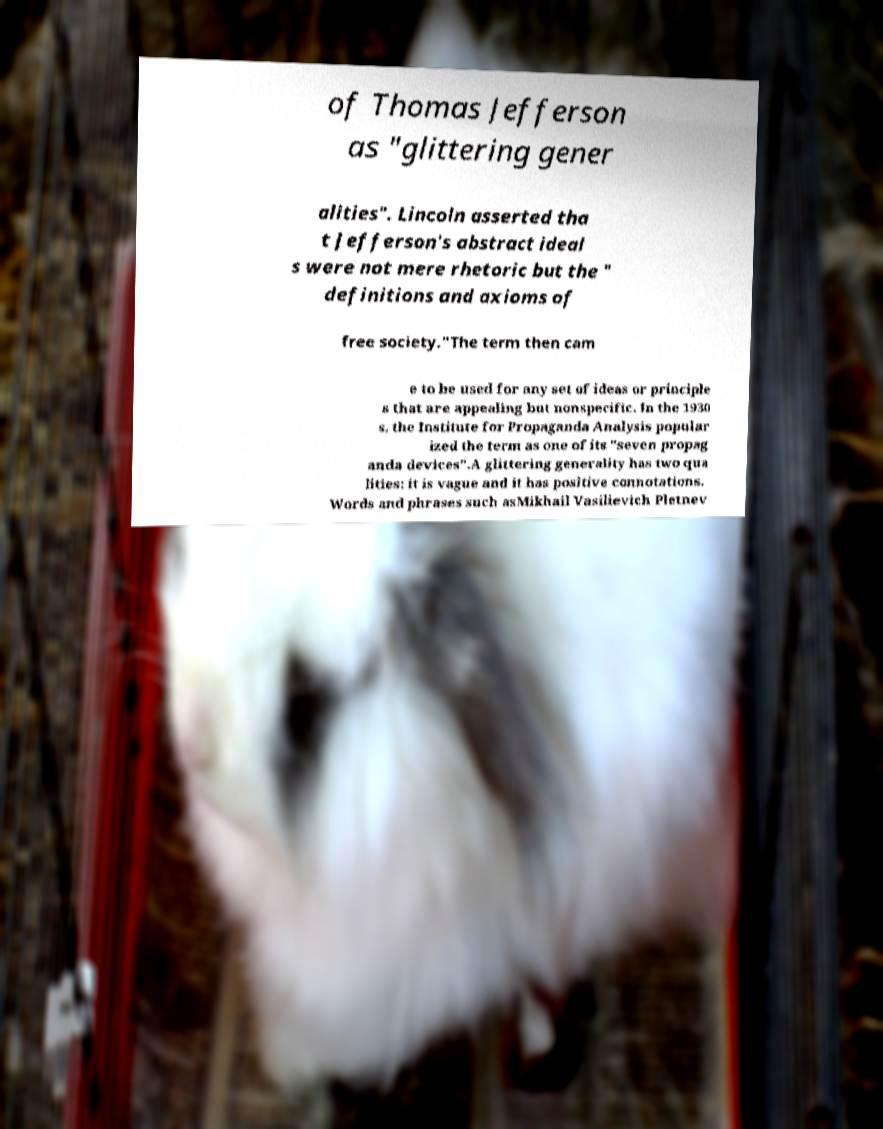What messages or text are displayed in this image? I need them in a readable, typed format. of Thomas Jefferson as "glittering gener alities". Lincoln asserted tha t Jefferson's abstract ideal s were not mere rhetoric but the " definitions and axioms of free society."The term then cam e to be used for any set of ideas or principle s that are appealing but nonspecific. In the 1930 s, the Institute for Propaganda Analysis popular ized the term as one of its "seven propag anda devices".A glittering generality has two qua lities: it is vague and it has positive connotations. Words and phrases such asMikhail Vasilievich Pletnev 